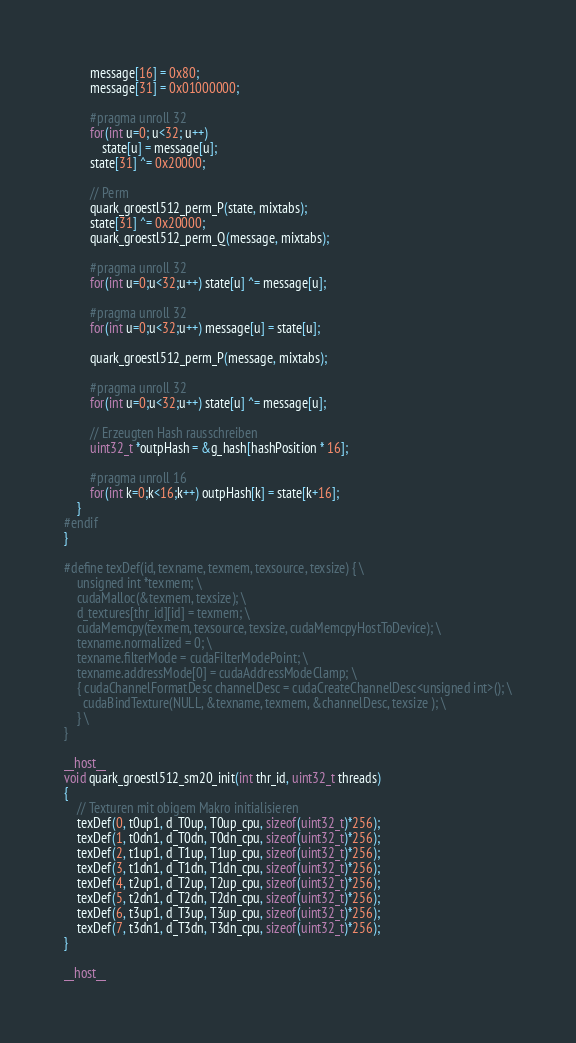Convert code to text. <code><loc_0><loc_0><loc_500><loc_500><_Cuda_>		message[16] = 0x80;
		message[31] = 0x01000000;

		#pragma unroll 32
		for(int u=0; u<32; u++)
			state[u] = message[u];
		state[31] ^= 0x20000;

		// Perm
		quark_groestl512_perm_P(state, mixtabs);
		state[31] ^= 0x20000;
		quark_groestl512_perm_Q(message, mixtabs);

		#pragma unroll 32
		for(int u=0;u<32;u++) state[u] ^= message[u];

		#pragma unroll 32
		for(int u=0;u<32;u++) message[u] = state[u];

		quark_groestl512_perm_P(message, mixtabs);

		#pragma unroll 32
		for(int u=0;u<32;u++) state[u] ^= message[u];

		// Erzeugten Hash rausschreiben
		uint32_t *outpHash = &g_hash[hashPosition * 16];

		#pragma unroll 16
		for(int k=0;k<16;k++) outpHash[k] = state[k+16];
	}
#endif
}

#define texDef(id, texname, texmem, texsource, texsize) { \
	unsigned int *texmem; \
	cudaMalloc(&texmem, texsize); \
	d_textures[thr_id][id] = texmem; \
	cudaMemcpy(texmem, texsource, texsize, cudaMemcpyHostToDevice); \
	texname.normalized = 0; \
	texname.filterMode = cudaFilterModePoint; \
	texname.addressMode[0] = cudaAddressModeClamp; \
	{ cudaChannelFormatDesc channelDesc = cudaCreateChannelDesc<unsigned int>(); \
	  cudaBindTexture(NULL, &texname, texmem, &channelDesc, texsize ); \
	} \
}

__host__
void quark_groestl512_sm20_init(int thr_id, uint32_t threads)
{
	// Texturen mit obigem Makro initialisieren
	texDef(0, t0up1, d_T0up, T0up_cpu, sizeof(uint32_t)*256);
	texDef(1, t0dn1, d_T0dn, T0dn_cpu, sizeof(uint32_t)*256);
	texDef(2, t1up1, d_T1up, T1up_cpu, sizeof(uint32_t)*256);
	texDef(3, t1dn1, d_T1dn, T1dn_cpu, sizeof(uint32_t)*256);
	texDef(4, t2up1, d_T2up, T2up_cpu, sizeof(uint32_t)*256);
	texDef(5, t2dn1, d_T2dn, T2dn_cpu, sizeof(uint32_t)*256);
	texDef(6, t3up1, d_T3up, T3up_cpu, sizeof(uint32_t)*256);
	texDef(7, t3dn1, d_T3dn, T3dn_cpu, sizeof(uint32_t)*256);
}

__host__</code> 